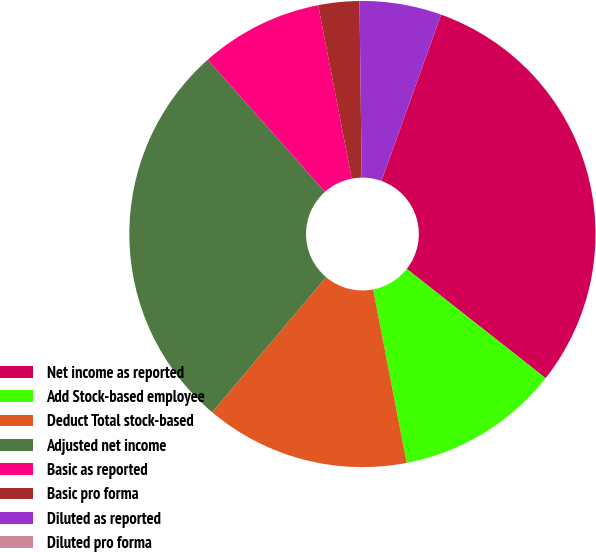Convert chart. <chart><loc_0><loc_0><loc_500><loc_500><pie_chart><fcel>Net income as reported<fcel>Add Stock-based employee<fcel>Deduct Total stock-based<fcel>Adjusted net income<fcel>Basic as reported<fcel>Basic pro forma<fcel>Diluted as reported<fcel>Diluted pro forma<nl><fcel>30.13%<fcel>11.35%<fcel>14.19%<fcel>27.3%<fcel>8.51%<fcel>2.84%<fcel>5.68%<fcel>0.0%<nl></chart> 